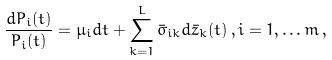Convert formula to latex. <formula><loc_0><loc_0><loc_500><loc_500>\frac { d P _ { i } ( t ) } { P _ { i } ( t ) } = \mu _ { i } d t + \sum _ { k = 1 } ^ { L } \bar { \sigma } _ { i k } d \bar { z } _ { k } ( t ) \, , i = 1 , \dots m \, ,</formula> 